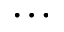Convert formula to latex. <formula><loc_0><loc_0><loc_500><loc_500>\dots</formula> 